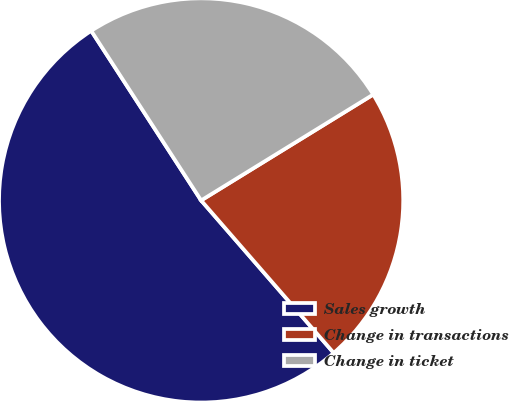Convert chart. <chart><loc_0><loc_0><loc_500><loc_500><pie_chart><fcel>Sales growth<fcel>Change in transactions<fcel>Change in ticket<nl><fcel>52.24%<fcel>22.39%<fcel>25.37%<nl></chart> 